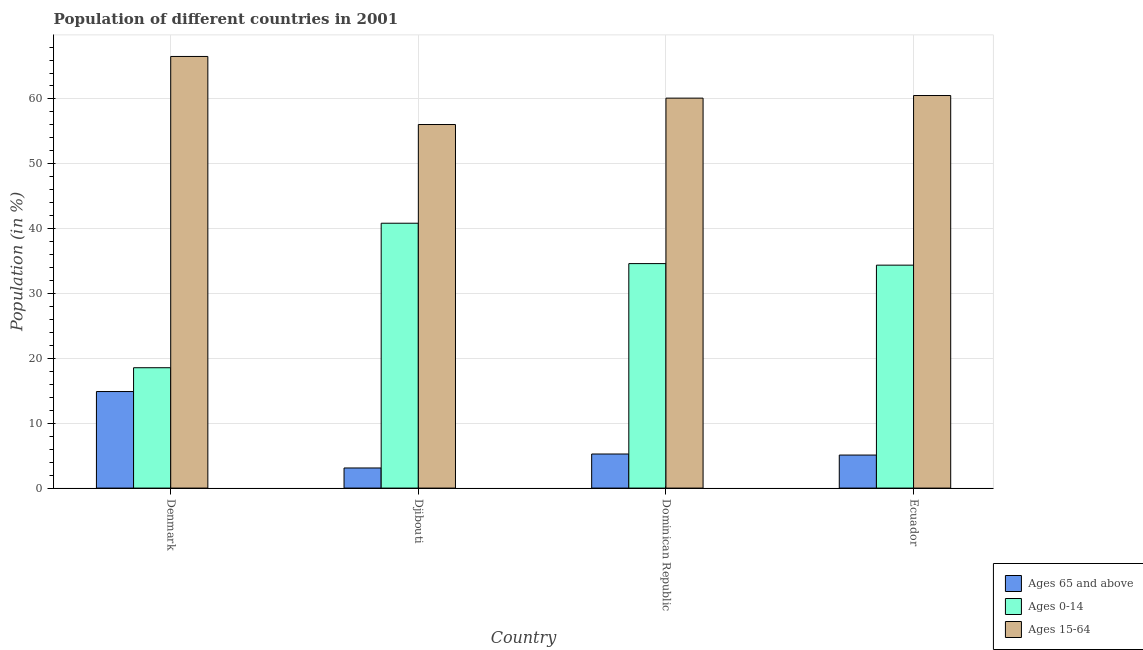Are the number of bars per tick equal to the number of legend labels?
Ensure brevity in your answer.  Yes. How many bars are there on the 3rd tick from the right?
Offer a terse response. 3. What is the label of the 3rd group of bars from the left?
Make the answer very short. Dominican Republic. In how many cases, is the number of bars for a given country not equal to the number of legend labels?
Your answer should be very brief. 0. What is the percentage of population within the age-group of 65 and above in Dominican Republic?
Ensure brevity in your answer.  5.26. Across all countries, what is the maximum percentage of population within the age-group 15-64?
Make the answer very short. 66.55. Across all countries, what is the minimum percentage of population within the age-group 15-64?
Provide a short and direct response. 56.06. In which country was the percentage of population within the age-group 15-64 maximum?
Ensure brevity in your answer.  Denmark. In which country was the percentage of population within the age-group 15-64 minimum?
Your response must be concise. Djibouti. What is the total percentage of population within the age-group of 65 and above in the graph?
Provide a succinct answer. 28.34. What is the difference between the percentage of population within the age-group of 65 and above in Djibouti and that in Ecuador?
Your answer should be compact. -1.99. What is the difference between the percentage of population within the age-group 0-14 in Denmark and the percentage of population within the age-group of 65 and above in Djibouti?
Ensure brevity in your answer.  15.46. What is the average percentage of population within the age-group of 65 and above per country?
Keep it short and to the point. 7.08. What is the difference between the percentage of population within the age-group of 65 and above and percentage of population within the age-group 0-14 in Ecuador?
Give a very brief answer. -29.28. What is the ratio of the percentage of population within the age-group of 65 and above in Dominican Republic to that in Ecuador?
Ensure brevity in your answer.  1.03. What is the difference between the highest and the second highest percentage of population within the age-group 15-64?
Ensure brevity in your answer.  6.02. What is the difference between the highest and the lowest percentage of population within the age-group of 65 and above?
Offer a terse response. 11.79. What does the 1st bar from the left in Djibouti represents?
Offer a terse response. Ages 65 and above. What does the 2nd bar from the right in Ecuador represents?
Make the answer very short. Ages 0-14. Are all the bars in the graph horizontal?
Give a very brief answer. No. Does the graph contain grids?
Make the answer very short. Yes. How many legend labels are there?
Make the answer very short. 3. How are the legend labels stacked?
Give a very brief answer. Vertical. What is the title of the graph?
Your response must be concise. Population of different countries in 2001. What is the label or title of the Y-axis?
Your answer should be compact. Population (in %). What is the Population (in %) in Ages 65 and above in Denmark?
Make the answer very short. 14.89. What is the Population (in %) of Ages 0-14 in Denmark?
Offer a very short reply. 18.56. What is the Population (in %) in Ages 15-64 in Denmark?
Ensure brevity in your answer.  66.55. What is the Population (in %) in Ages 65 and above in Djibouti?
Offer a very short reply. 3.1. What is the Population (in %) of Ages 0-14 in Djibouti?
Make the answer very short. 40.84. What is the Population (in %) of Ages 15-64 in Djibouti?
Your answer should be compact. 56.06. What is the Population (in %) in Ages 65 and above in Dominican Republic?
Offer a terse response. 5.26. What is the Population (in %) in Ages 0-14 in Dominican Republic?
Your answer should be very brief. 34.62. What is the Population (in %) in Ages 15-64 in Dominican Republic?
Give a very brief answer. 60.13. What is the Population (in %) in Ages 65 and above in Ecuador?
Your answer should be very brief. 5.09. What is the Population (in %) in Ages 0-14 in Ecuador?
Ensure brevity in your answer.  34.38. What is the Population (in %) in Ages 15-64 in Ecuador?
Keep it short and to the point. 60.53. Across all countries, what is the maximum Population (in %) in Ages 65 and above?
Keep it short and to the point. 14.89. Across all countries, what is the maximum Population (in %) in Ages 0-14?
Give a very brief answer. 40.84. Across all countries, what is the maximum Population (in %) in Ages 15-64?
Give a very brief answer. 66.55. Across all countries, what is the minimum Population (in %) in Ages 65 and above?
Keep it short and to the point. 3.1. Across all countries, what is the minimum Population (in %) in Ages 0-14?
Your answer should be compact. 18.56. Across all countries, what is the minimum Population (in %) in Ages 15-64?
Your response must be concise. 56.06. What is the total Population (in %) of Ages 65 and above in the graph?
Your answer should be compact. 28.34. What is the total Population (in %) in Ages 0-14 in the graph?
Provide a short and direct response. 128.39. What is the total Population (in %) of Ages 15-64 in the graph?
Your answer should be very brief. 243.27. What is the difference between the Population (in %) in Ages 65 and above in Denmark and that in Djibouti?
Your response must be concise. 11.79. What is the difference between the Population (in %) in Ages 0-14 in Denmark and that in Djibouti?
Provide a succinct answer. -22.28. What is the difference between the Population (in %) in Ages 15-64 in Denmark and that in Djibouti?
Your answer should be compact. 10.49. What is the difference between the Population (in %) of Ages 65 and above in Denmark and that in Dominican Republic?
Provide a short and direct response. 9.63. What is the difference between the Population (in %) of Ages 0-14 in Denmark and that in Dominican Republic?
Your response must be concise. -16.06. What is the difference between the Population (in %) in Ages 15-64 in Denmark and that in Dominican Republic?
Your answer should be very brief. 6.42. What is the difference between the Population (in %) of Ages 65 and above in Denmark and that in Ecuador?
Make the answer very short. 9.79. What is the difference between the Population (in %) in Ages 0-14 in Denmark and that in Ecuador?
Give a very brief answer. -15.82. What is the difference between the Population (in %) in Ages 15-64 in Denmark and that in Ecuador?
Your answer should be compact. 6.02. What is the difference between the Population (in %) in Ages 65 and above in Djibouti and that in Dominican Republic?
Offer a terse response. -2.15. What is the difference between the Population (in %) of Ages 0-14 in Djibouti and that in Dominican Republic?
Offer a very short reply. 6.22. What is the difference between the Population (in %) of Ages 15-64 in Djibouti and that in Dominican Republic?
Offer a terse response. -4.07. What is the difference between the Population (in %) of Ages 65 and above in Djibouti and that in Ecuador?
Your answer should be compact. -1.99. What is the difference between the Population (in %) in Ages 0-14 in Djibouti and that in Ecuador?
Your answer should be very brief. 6.46. What is the difference between the Population (in %) of Ages 15-64 in Djibouti and that in Ecuador?
Provide a short and direct response. -4.47. What is the difference between the Population (in %) of Ages 65 and above in Dominican Republic and that in Ecuador?
Give a very brief answer. 0.16. What is the difference between the Population (in %) in Ages 0-14 in Dominican Republic and that in Ecuador?
Ensure brevity in your answer.  0.24. What is the difference between the Population (in %) of Ages 15-64 in Dominican Republic and that in Ecuador?
Offer a terse response. -0.4. What is the difference between the Population (in %) in Ages 65 and above in Denmark and the Population (in %) in Ages 0-14 in Djibouti?
Your answer should be very brief. -25.95. What is the difference between the Population (in %) of Ages 65 and above in Denmark and the Population (in %) of Ages 15-64 in Djibouti?
Give a very brief answer. -41.17. What is the difference between the Population (in %) in Ages 0-14 in Denmark and the Population (in %) in Ages 15-64 in Djibouti?
Give a very brief answer. -37.5. What is the difference between the Population (in %) in Ages 65 and above in Denmark and the Population (in %) in Ages 0-14 in Dominican Republic?
Give a very brief answer. -19.73. What is the difference between the Population (in %) in Ages 65 and above in Denmark and the Population (in %) in Ages 15-64 in Dominican Republic?
Keep it short and to the point. -45.24. What is the difference between the Population (in %) in Ages 0-14 in Denmark and the Population (in %) in Ages 15-64 in Dominican Republic?
Ensure brevity in your answer.  -41.57. What is the difference between the Population (in %) in Ages 65 and above in Denmark and the Population (in %) in Ages 0-14 in Ecuador?
Provide a succinct answer. -19.49. What is the difference between the Population (in %) of Ages 65 and above in Denmark and the Population (in %) of Ages 15-64 in Ecuador?
Offer a very short reply. -45.64. What is the difference between the Population (in %) of Ages 0-14 in Denmark and the Population (in %) of Ages 15-64 in Ecuador?
Provide a succinct answer. -41.97. What is the difference between the Population (in %) of Ages 65 and above in Djibouti and the Population (in %) of Ages 0-14 in Dominican Republic?
Give a very brief answer. -31.51. What is the difference between the Population (in %) of Ages 65 and above in Djibouti and the Population (in %) of Ages 15-64 in Dominican Republic?
Provide a succinct answer. -57.03. What is the difference between the Population (in %) in Ages 0-14 in Djibouti and the Population (in %) in Ages 15-64 in Dominican Republic?
Give a very brief answer. -19.29. What is the difference between the Population (in %) of Ages 65 and above in Djibouti and the Population (in %) of Ages 0-14 in Ecuador?
Ensure brevity in your answer.  -31.27. What is the difference between the Population (in %) in Ages 65 and above in Djibouti and the Population (in %) in Ages 15-64 in Ecuador?
Give a very brief answer. -57.43. What is the difference between the Population (in %) of Ages 0-14 in Djibouti and the Population (in %) of Ages 15-64 in Ecuador?
Keep it short and to the point. -19.69. What is the difference between the Population (in %) of Ages 65 and above in Dominican Republic and the Population (in %) of Ages 0-14 in Ecuador?
Offer a terse response. -29.12. What is the difference between the Population (in %) of Ages 65 and above in Dominican Republic and the Population (in %) of Ages 15-64 in Ecuador?
Your answer should be very brief. -55.27. What is the difference between the Population (in %) of Ages 0-14 in Dominican Republic and the Population (in %) of Ages 15-64 in Ecuador?
Ensure brevity in your answer.  -25.91. What is the average Population (in %) of Ages 65 and above per country?
Offer a very short reply. 7.08. What is the average Population (in %) of Ages 0-14 per country?
Make the answer very short. 32.1. What is the average Population (in %) of Ages 15-64 per country?
Provide a short and direct response. 60.82. What is the difference between the Population (in %) in Ages 65 and above and Population (in %) in Ages 0-14 in Denmark?
Offer a very short reply. -3.67. What is the difference between the Population (in %) in Ages 65 and above and Population (in %) in Ages 15-64 in Denmark?
Ensure brevity in your answer.  -51.67. What is the difference between the Population (in %) of Ages 0-14 and Population (in %) of Ages 15-64 in Denmark?
Your response must be concise. -47.99. What is the difference between the Population (in %) of Ages 65 and above and Population (in %) of Ages 0-14 in Djibouti?
Your answer should be very brief. -37.74. What is the difference between the Population (in %) in Ages 65 and above and Population (in %) in Ages 15-64 in Djibouti?
Keep it short and to the point. -52.96. What is the difference between the Population (in %) of Ages 0-14 and Population (in %) of Ages 15-64 in Djibouti?
Keep it short and to the point. -15.22. What is the difference between the Population (in %) of Ages 65 and above and Population (in %) of Ages 0-14 in Dominican Republic?
Your answer should be very brief. -29.36. What is the difference between the Population (in %) in Ages 65 and above and Population (in %) in Ages 15-64 in Dominican Republic?
Provide a short and direct response. -54.87. What is the difference between the Population (in %) of Ages 0-14 and Population (in %) of Ages 15-64 in Dominican Republic?
Offer a terse response. -25.51. What is the difference between the Population (in %) in Ages 65 and above and Population (in %) in Ages 0-14 in Ecuador?
Your answer should be compact. -29.28. What is the difference between the Population (in %) in Ages 65 and above and Population (in %) in Ages 15-64 in Ecuador?
Make the answer very short. -55.44. What is the difference between the Population (in %) of Ages 0-14 and Population (in %) of Ages 15-64 in Ecuador?
Ensure brevity in your answer.  -26.15. What is the ratio of the Population (in %) in Ages 65 and above in Denmark to that in Djibouti?
Your answer should be compact. 4.8. What is the ratio of the Population (in %) in Ages 0-14 in Denmark to that in Djibouti?
Ensure brevity in your answer.  0.45. What is the ratio of the Population (in %) in Ages 15-64 in Denmark to that in Djibouti?
Offer a terse response. 1.19. What is the ratio of the Population (in %) of Ages 65 and above in Denmark to that in Dominican Republic?
Your answer should be very brief. 2.83. What is the ratio of the Population (in %) of Ages 0-14 in Denmark to that in Dominican Republic?
Give a very brief answer. 0.54. What is the ratio of the Population (in %) in Ages 15-64 in Denmark to that in Dominican Republic?
Keep it short and to the point. 1.11. What is the ratio of the Population (in %) in Ages 65 and above in Denmark to that in Ecuador?
Your response must be concise. 2.92. What is the ratio of the Population (in %) in Ages 0-14 in Denmark to that in Ecuador?
Give a very brief answer. 0.54. What is the ratio of the Population (in %) of Ages 15-64 in Denmark to that in Ecuador?
Give a very brief answer. 1.1. What is the ratio of the Population (in %) of Ages 65 and above in Djibouti to that in Dominican Republic?
Offer a terse response. 0.59. What is the ratio of the Population (in %) of Ages 0-14 in Djibouti to that in Dominican Republic?
Provide a short and direct response. 1.18. What is the ratio of the Population (in %) of Ages 15-64 in Djibouti to that in Dominican Republic?
Your answer should be compact. 0.93. What is the ratio of the Population (in %) in Ages 65 and above in Djibouti to that in Ecuador?
Your answer should be very brief. 0.61. What is the ratio of the Population (in %) of Ages 0-14 in Djibouti to that in Ecuador?
Make the answer very short. 1.19. What is the ratio of the Population (in %) in Ages 15-64 in Djibouti to that in Ecuador?
Provide a succinct answer. 0.93. What is the ratio of the Population (in %) in Ages 65 and above in Dominican Republic to that in Ecuador?
Provide a short and direct response. 1.03. What is the ratio of the Population (in %) in Ages 0-14 in Dominican Republic to that in Ecuador?
Your response must be concise. 1.01. What is the difference between the highest and the second highest Population (in %) in Ages 65 and above?
Ensure brevity in your answer.  9.63. What is the difference between the highest and the second highest Population (in %) in Ages 0-14?
Your response must be concise. 6.22. What is the difference between the highest and the second highest Population (in %) in Ages 15-64?
Offer a terse response. 6.02. What is the difference between the highest and the lowest Population (in %) in Ages 65 and above?
Your response must be concise. 11.79. What is the difference between the highest and the lowest Population (in %) in Ages 0-14?
Your response must be concise. 22.28. What is the difference between the highest and the lowest Population (in %) in Ages 15-64?
Make the answer very short. 10.49. 